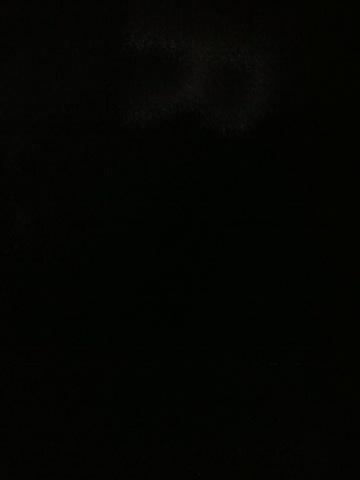Can you describe what you see in this image? The image appears to be very dark, and it is difficult to make out any specific objects or details. It seems like additional lighting or a clearer image would be helpful for a more accurate description. 